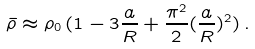Convert formula to latex. <formula><loc_0><loc_0><loc_500><loc_500>\bar { \rho } \approx \rho _ { 0 } \, ( 1 - 3 \frac { a } { R } + \frac { \pi ^ { 2 } } { 2 } ( \frac { a } { R } ) ^ { 2 } ) \, .</formula> 